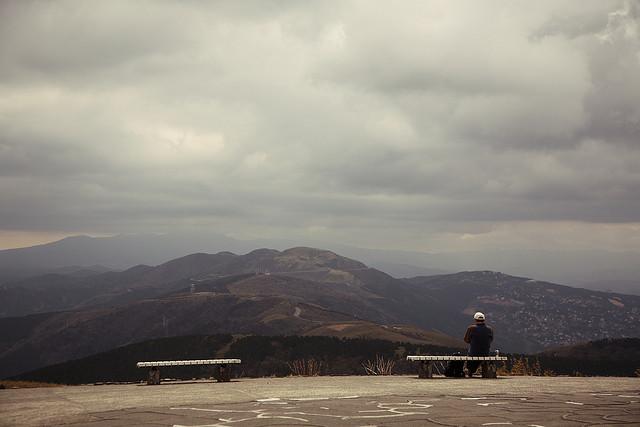What is in the background?
Write a very short answer. Mountains. Are those hills at the back?
Concise answer only. Yes. Is the man on the bench to the right or to the left?
Give a very brief answer. Right. Is this an inspirational scene?
Quick response, please. Yes. Is it raining in the picture?
Concise answer only. No. Is the sun out?
Answer briefly. No. What is the photographer standing between?
Answer briefly. Benches. 